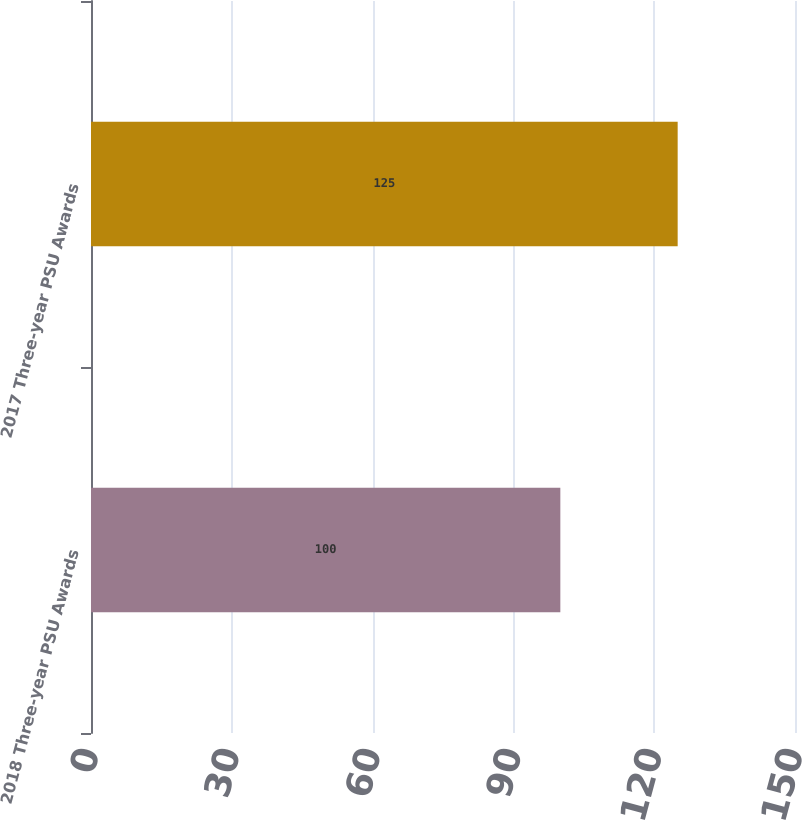<chart> <loc_0><loc_0><loc_500><loc_500><bar_chart><fcel>2018 Three-year PSU Awards<fcel>2017 Three-year PSU Awards<nl><fcel>100<fcel>125<nl></chart> 